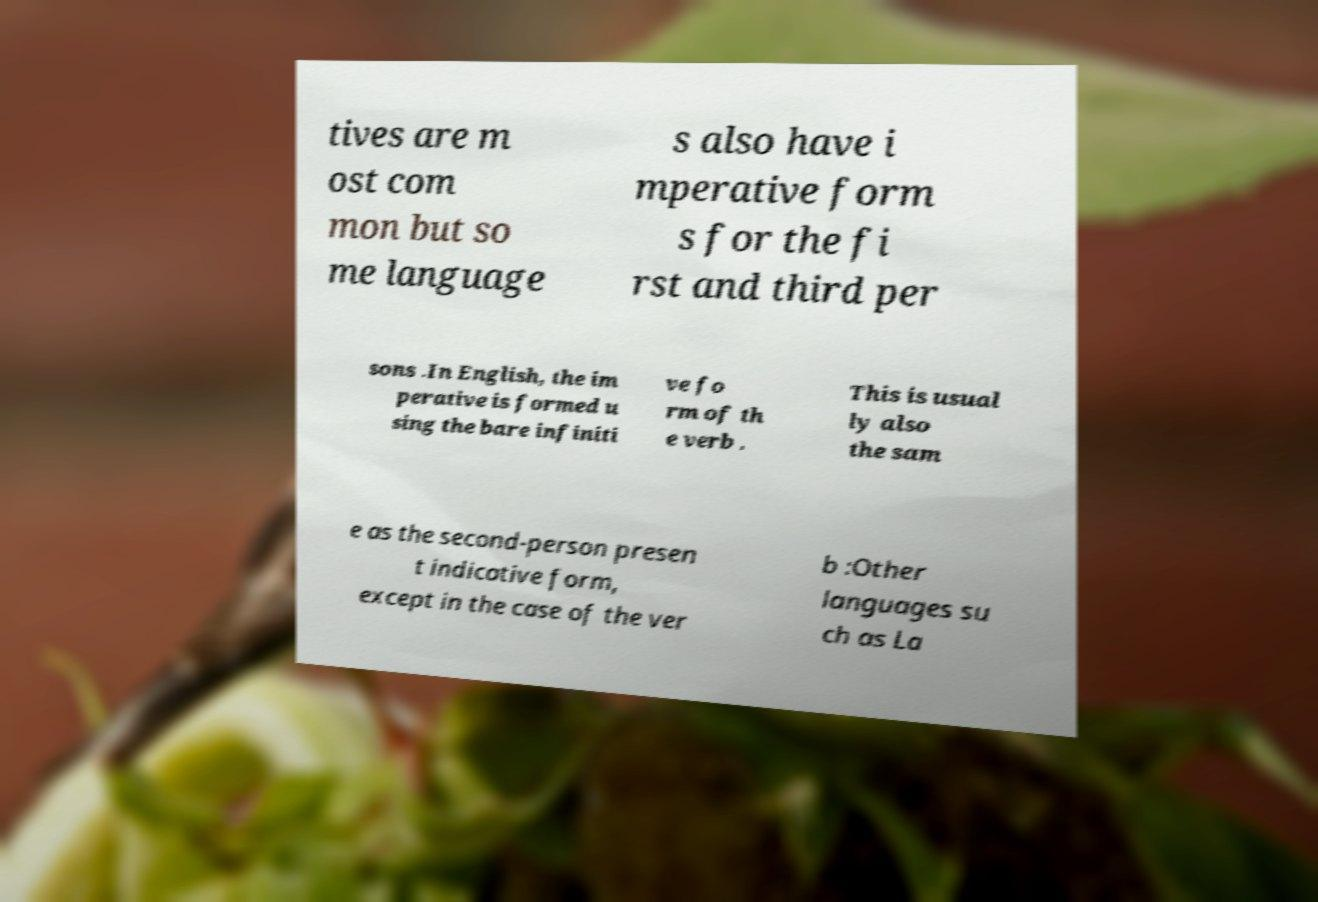Please identify and transcribe the text found in this image. tives are m ost com mon but so me language s also have i mperative form s for the fi rst and third per sons .In English, the im perative is formed u sing the bare infiniti ve fo rm of th e verb . This is usual ly also the sam e as the second-person presen t indicative form, except in the case of the ver b :Other languages su ch as La 